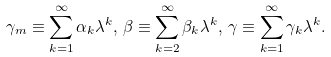Convert formula to latex. <formula><loc_0><loc_0><loc_500><loc_500>\gamma _ { m } \equiv \sum _ { k = 1 } ^ { \infty } \alpha _ { k } \lambda ^ { k } , \, \beta \equiv \sum _ { k = 2 } ^ { \infty } \beta _ { k } \lambda ^ { k } , \, \gamma \equiv \sum _ { k = 1 } ^ { \infty } \gamma _ { k } \lambda ^ { k } .</formula> 